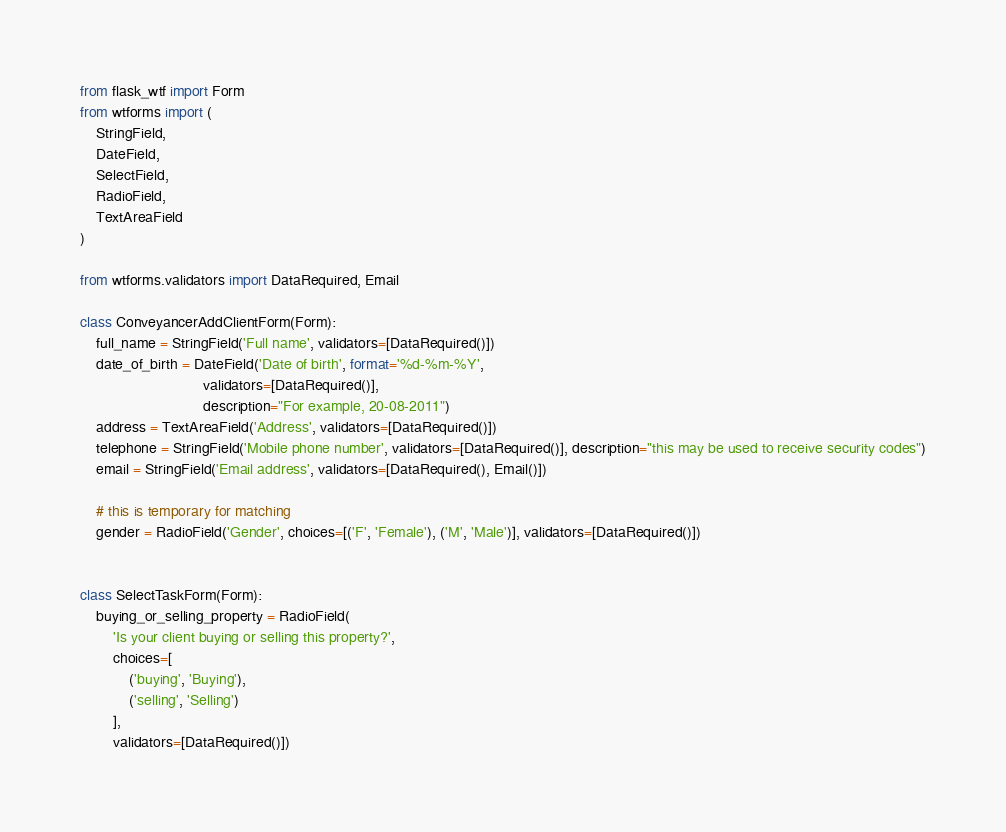<code> <loc_0><loc_0><loc_500><loc_500><_Python_>from flask_wtf import Form
from wtforms import (
    StringField,
    DateField,
    SelectField,
    RadioField,
    TextAreaField
)

from wtforms.validators import DataRequired, Email

class ConveyancerAddClientForm(Form):
    full_name = StringField('Full name', validators=[DataRequired()])
    date_of_birth = DateField('Date of birth', format='%d-%m-%Y',
                              validators=[DataRequired()],
                              description="For example, 20-08-2011")
    address = TextAreaField('Address', validators=[DataRequired()])
    telephone = StringField('Mobile phone number', validators=[DataRequired()], description="this may be used to receive security codes")
    email = StringField('Email address', validators=[DataRequired(), Email()])

    # this is temporary for matching
    gender = RadioField('Gender', choices=[('F', 'Female'), ('M', 'Male')], validators=[DataRequired()])


class SelectTaskForm(Form):
    buying_or_selling_property = RadioField(
        'Is your client buying or selling this property?',
        choices=[
            ('buying', 'Buying'),
            ('selling', 'Selling')
        ],
        validators=[DataRequired()])
</code> 